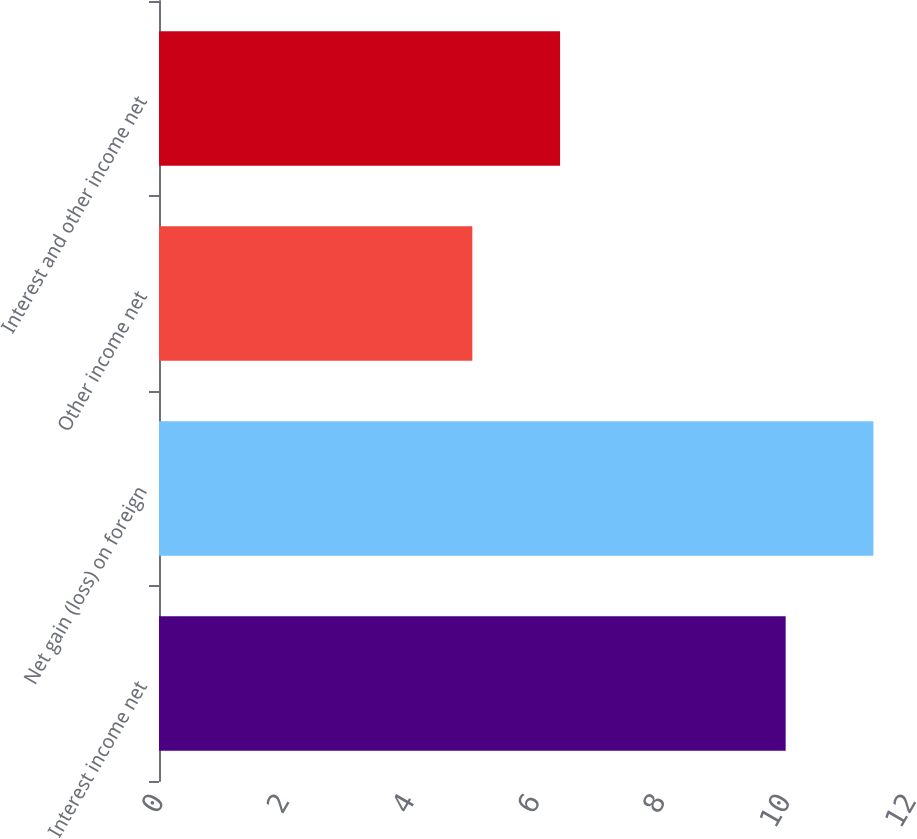Convert chart. <chart><loc_0><loc_0><loc_500><loc_500><bar_chart><fcel>Interest income net<fcel>Net gain (loss) on foreign<fcel>Other income net<fcel>Interest and other income net<nl><fcel>10<fcel>11.4<fcel>5<fcel>6.4<nl></chart> 